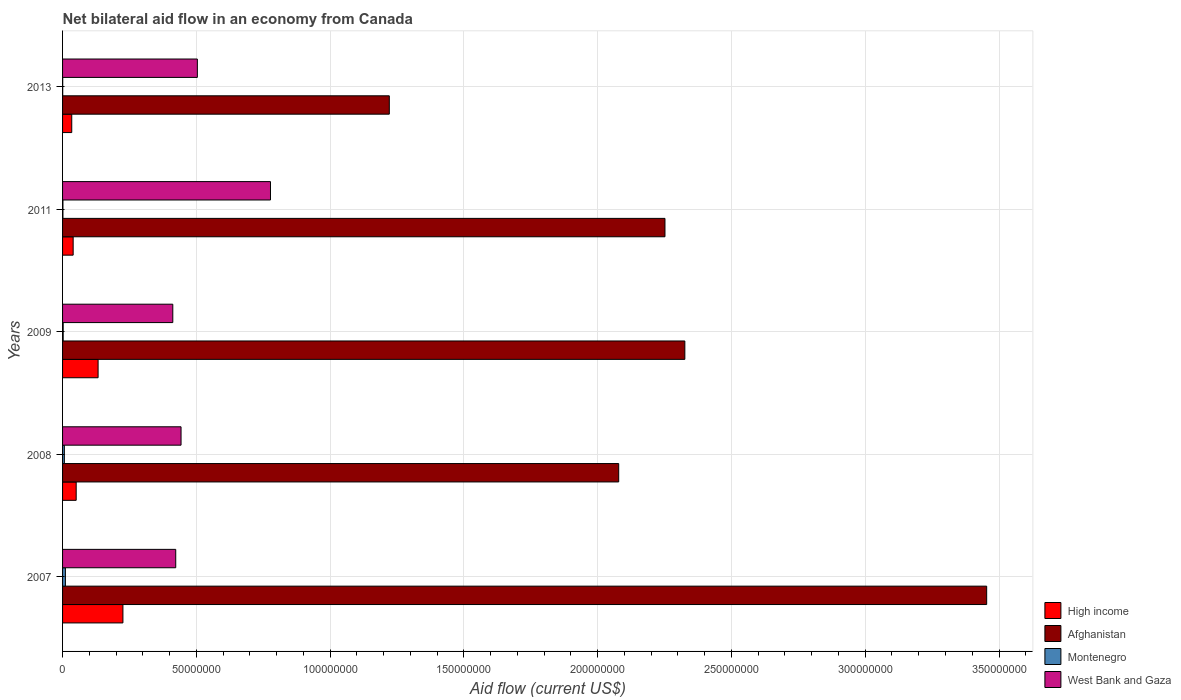How many different coloured bars are there?
Offer a very short reply. 4. How many groups of bars are there?
Offer a terse response. 5. Are the number of bars per tick equal to the number of legend labels?
Your answer should be very brief. Yes. How many bars are there on the 2nd tick from the bottom?
Your response must be concise. 4. In how many cases, is the number of bars for a given year not equal to the number of legend labels?
Ensure brevity in your answer.  0. What is the net bilateral aid flow in Afghanistan in 2011?
Keep it short and to the point. 2.25e+08. Across all years, what is the maximum net bilateral aid flow in Afghanistan?
Your answer should be very brief. 3.45e+08. What is the total net bilateral aid flow in Montenegro in the graph?
Give a very brief answer. 2.15e+06. What is the difference between the net bilateral aid flow in Montenegro in 2008 and that in 2011?
Your answer should be very brief. 5.30e+05. What is the difference between the net bilateral aid flow in Montenegro in 2009 and the net bilateral aid flow in Afghanistan in 2013?
Provide a short and direct response. -1.22e+08. In the year 2009, what is the difference between the net bilateral aid flow in Afghanistan and net bilateral aid flow in Montenegro?
Offer a very short reply. 2.32e+08. In how many years, is the net bilateral aid flow in West Bank and Gaza greater than 10000000 US$?
Offer a terse response. 5. What is the difference between the highest and the second highest net bilateral aid flow in High income?
Provide a short and direct response. 9.28e+06. What is the difference between the highest and the lowest net bilateral aid flow in Afghanistan?
Provide a succinct answer. 2.23e+08. In how many years, is the net bilateral aid flow in Montenegro greater than the average net bilateral aid flow in Montenegro taken over all years?
Give a very brief answer. 2. Is the sum of the net bilateral aid flow in Montenegro in 2007 and 2011 greater than the maximum net bilateral aid flow in West Bank and Gaza across all years?
Your answer should be compact. No. Is it the case that in every year, the sum of the net bilateral aid flow in Montenegro and net bilateral aid flow in West Bank and Gaza is greater than the sum of net bilateral aid flow in High income and net bilateral aid flow in Afghanistan?
Ensure brevity in your answer.  Yes. What does the 3rd bar from the top in 2011 represents?
Your answer should be very brief. Afghanistan. What does the 3rd bar from the bottom in 2008 represents?
Offer a terse response. Montenegro. How many bars are there?
Your answer should be compact. 20. Are all the bars in the graph horizontal?
Provide a succinct answer. Yes. How many years are there in the graph?
Your answer should be compact. 5. Are the values on the major ticks of X-axis written in scientific E-notation?
Keep it short and to the point. No. Does the graph contain grids?
Offer a very short reply. Yes. Where does the legend appear in the graph?
Your answer should be compact. Bottom right. How are the legend labels stacked?
Give a very brief answer. Vertical. What is the title of the graph?
Provide a short and direct response. Net bilateral aid flow in an economy from Canada. What is the label or title of the X-axis?
Keep it short and to the point. Aid flow (current US$). What is the label or title of the Y-axis?
Give a very brief answer. Years. What is the Aid flow (current US$) in High income in 2007?
Offer a terse response. 2.26e+07. What is the Aid flow (current US$) of Afghanistan in 2007?
Your answer should be very brief. 3.45e+08. What is the Aid flow (current US$) in Montenegro in 2007?
Offer a very short reply. 1.06e+06. What is the Aid flow (current US$) of West Bank and Gaza in 2007?
Keep it short and to the point. 4.23e+07. What is the Aid flow (current US$) of High income in 2008?
Provide a succinct answer. 5.09e+06. What is the Aid flow (current US$) in Afghanistan in 2008?
Make the answer very short. 2.08e+08. What is the Aid flow (current US$) in Montenegro in 2008?
Your answer should be compact. 6.70e+05. What is the Aid flow (current US$) in West Bank and Gaza in 2008?
Your answer should be compact. 4.43e+07. What is the Aid flow (current US$) of High income in 2009?
Provide a succinct answer. 1.33e+07. What is the Aid flow (current US$) of Afghanistan in 2009?
Ensure brevity in your answer.  2.33e+08. What is the Aid flow (current US$) in Montenegro in 2009?
Your answer should be compact. 2.30e+05. What is the Aid flow (current US$) in West Bank and Gaza in 2009?
Offer a very short reply. 4.12e+07. What is the Aid flow (current US$) in High income in 2011?
Provide a succinct answer. 3.96e+06. What is the Aid flow (current US$) of Afghanistan in 2011?
Give a very brief answer. 2.25e+08. What is the Aid flow (current US$) in Montenegro in 2011?
Make the answer very short. 1.40e+05. What is the Aid flow (current US$) in West Bank and Gaza in 2011?
Keep it short and to the point. 7.77e+07. What is the Aid flow (current US$) in High income in 2013?
Make the answer very short. 3.43e+06. What is the Aid flow (current US$) in Afghanistan in 2013?
Your answer should be compact. 1.22e+08. What is the Aid flow (current US$) in Montenegro in 2013?
Ensure brevity in your answer.  5.00e+04. What is the Aid flow (current US$) in West Bank and Gaza in 2013?
Your answer should be very brief. 5.04e+07. Across all years, what is the maximum Aid flow (current US$) in High income?
Your answer should be compact. 2.26e+07. Across all years, what is the maximum Aid flow (current US$) of Afghanistan?
Your answer should be very brief. 3.45e+08. Across all years, what is the maximum Aid flow (current US$) of Montenegro?
Your answer should be compact. 1.06e+06. Across all years, what is the maximum Aid flow (current US$) of West Bank and Gaza?
Provide a succinct answer. 7.77e+07. Across all years, what is the minimum Aid flow (current US$) in High income?
Provide a succinct answer. 3.43e+06. Across all years, what is the minimum Aid flow (current US$) in Afghanistan?
Keep it short and to the point. 1.22e+08. Across all years, what is the minimum Aid flow (current US$) of Montenegro?
Your answer should be compact. 5.00e+04. Across all years, what is the minimum Aid flow (current US$) in West Bank and Gaza?
Offer a very short reply. 4.12e+07. What is the total Aid flow (current US$) in High income in the graph?
Keep it short and to the point. 4.83e+07. What is the total Aid flow (current US$) in Afghanistan in the graph?
Keep it short and to the point. 1.13e+09. What is the total Aid flow (current US$) in Montenegro in the graph?
Your response must be concise. 2.15e+06. What is the total Aid flow (current US$) in West Bank and Gaza in the graph?
Ensure brevity in your answer.  2.56e+08. What is the difference between the Aid flow (current US$) of High income in 2007 and that in 2008?
Keep it short and to the point. 1.75e+07. What is the difference between the Aid flow (current US$) in Afghanistan in 2007 and that in 2008?
Your answer should be very brief. 1.38e+08. What is the difference between the Aid flow (current US$) of West Bank and Gaza in 2007 and that in 2008?
Offer a terse response. -1.98e+06. What is the difference between the Aid flow (current US$) in High income in 2007 and that in 2009?
Your answer should be compact. 9.28e+06. What is the difference between the Aid flow (current US$) of Afghanistan in 2007 and that in 2009?
Provide a short and direct response. 1.13e+08. What is the difference between the Aid flow (current US$) in Montenegro in 2007 and that in 2009?
Ensure brevity in your answer.  8.30e+05. What is the difference between the Aid flow (current US$) of West Bank and Gaza in 2007 and that in 2009?
Keep it short and to the point. 1.10e+06. What is the difference between the Aid flow (current US$) of High income in 2007 and that in 2011?
Offer a very short reply. 1.86e+07. What is the difference between the Aid flow (current US$) of Afghanistan in 2007 and that in 2011?
Keep it short and to the point. 1.20e+08. What is the difference between the Aid flow (current US$) of Montenegro in 2007 and that in 2011?
Provide a succinct answer. 9.20e+05. What is the difference between the Aid flow (current US$) of West Bank and Gaza in 2007 and that in 2011?
Provide a succinct answer. -3.54e+07. What is the difference between the Aid flow (current US$) of High income in 2007 and that in 2013?
Your answer should be very brief. 1.91e+07. What is the difference between the Aid flow (current US$) in Afghanistan in 2007 and that in 2013?
Provide a succinct answer. 2.23e+08. What is the difference between the Aid flow (current US$) of Montenegro in 2007 and that in 2013?
Provide a succinct answer. 1.01e+06. What is the difference between the Aid flow (current US$) in West Bank and Gaza in 2007 and that in 2013?
Your response must be concise. -8.08e+06. What is the difference between the Aid flow (current US$) in High income in 2008 and that in 2009?
Offer a terse response. -8.19e+06. What is the difference between the Aid flow (current US$) in Afghanistan in 2008 and that in 2009?
Give a very brief answer. -2.47e+07. What is the difference between the Aid flow (current US$) in Montenegro in 2008 and that in 2009?
Your answer should be compact. 4.40e+05. What is the difference between the Aid flow (current US$) of West Bank and Gaza in 2008 and that in 2009?
Your answer should be compact. 3.08e+06. What is the difference between the Aid flow (current US$) in High income in 2008 and that in 2011?
Ensure brevity in your answer.  1.13e+06. What is the difference between the Aid flow (current US$) in Afghanistan in 2008 and that in 2011?
Make the answer very short. -1.73e+07. What is the difference between the Aid flow (current US$) of Montenegro in 2008 and that in 2011?
Provide a short and direct response. 5.30e+05. What is the difference between the Aid flow (current US$) of West Bank and Gaza in 2008 and that in 2011?
Provide a short and direct response. -3.34e+07. What is the difference between the Aid flow (current US$) of High income in 2008 and that in 2013?
Your response must be concise. 1.66e+06. What is the difference between the Aid flow (current US$) in Afghanistan in 2008 and that in 2013?
Make the answer very short. 8.57e+07. What is the difference between the Aid flow (current US$) in Montenegro in 2008 and that in 2013?
Ensure brevity in your answer.  6.20e+05. What is the difference between the Aid flow (current US$) in West Bank and Gaza in 2008 and that in 2013?
Make the answer very short. -6.10e+06. What is the difference between the Aid flow (current US$) in High income in 2009 and that in 2011?
Give a very brief answer. 9.32e+06. What is the difference between the Aid flow (current US$) in Afghanistan in 2009 and that in 2011?
Keep it short and to the point. 7.43e+06. What is the difference between the Aid flow (current US$) in West Bank and Gaza in 2009 and that in 2011?
Give a very brief answer. -3.65e+07. What is the difference between the Aid flow (current US$) of High income in 2009 and that in 2013?
Offer a terse response. 9.85e+06. What is the difference between the Aid flow (current US$) of Afghanistan in 2009 and that in 2013?
Offer a terse response. 1.10e+08. What is the difference between the Aid flow (current US$) of West Bank and Gaza in 2009 and that in 2013?
Give a very brief answer. -9.18e+06. What is the difference between the Aid flow (current US$) in High income in 2011 and that in 2013?
Ensure brevity in your answer.  5.30e+05. What is the difference between the Aid flow (current US$) of Afghanistan in 2011 and that in 2013?
Keep it short and to the point. 1.03e+08. What is the difference between the Aid flow (current US$) in West Bank and Gaza in 2011 and that in 2013?
Your response must be concise. 2.73e+07. What is the difference between the Aid flow (current US$) in High income in 2007 and the Aid flow (current US$) in Afghanistan in 2008?
Your response must be concise. -1.85e+08. What is the difference between the Aid flow (current US$) of High income in 2007 and the Aid flow (current US$) of Montenegro in 2008?
Provide a short and direct response. 2.19e+07. What is the difference between the Aid flow (current US$) of High income in 2007 and the Aid flow (current US$) of West Bank and Gaza in 2008?
Provide a succinct answer. -2.17e+07. What is the difference between the Aid flow (current US$) in Afghanistan in 2007 and the Aid flow (current US$) in Montenegro in 2008?
Your answer should be compact. 3.45e+08. What is the difference between the Aid flow (current US$) of Afghanistan in 2007 and the Aid flow (current US$) of West Bank and Gaza in 2008?
Provide a succinct answer. 3.01e+08. What is the difference between the Aid flow (current US$) of Montenegro in 2007 and the Aid flow (current US$) of West Bank and Gaza in 2008?
Offer a very short reply. -4.32e+07. What is the difference between the Aid flow (current US$) in High income in 2007 and the Aid flow (current US$) in Afghanistan in 2009?
Your answer should be very brief. -2.10e+08. What is the difference between the Aid flow (current US$) in High income in 2007 and the Aid flow (current US$) in Montenegro in 2009?
Make the answer very short. 2.23e+07. What is the difference between the Aid flow (current US$) in High income in 2007 and the Aid flow (current US$) in West Bank and Gaza in 2009?
Offer a terse response. -1.86e+07. What is the difference between the Aid flow (current US$) of Afghanistan in 2007 and the Aid flow (current US$) of Montenegro in 2009?
Provide a succinct answer. 3.45e+08. What is the difference between the Aid flow (current US$) of Afghanistan in 2007 and the Aid flow (current US$) of West Bank and Gaza in 2009?
Your response must be concise. 3.04e+08. What is the difference between the Aid flow (current US$) of Montenegro in 2007 and the Aid flow (current US$) of West Bank and Gaza in 2009?
Provide a succinct answer. -4.01e+07. What is the difference between the Aid flow (current US$) in High income in 2007 and the Aid flow (current US$) in Afghanistan in 2011?
Your answer should be compact. -2.03e+08. What is the difference between the Aid flow (current US$) in High income in 2007 and the Aid flow (current US$) in Montenegro in 2011?
Your answer should be very brief. 2.24e+07. What is the difference between the Aid flow (current US$) of High income in 2007 and the Aid flow (current US$) of West Bank and Gaza in 2011?
Offer a very short reply. -5.52e+07. What is the difference between the Aid flow (current US$) of Afghanistan in 2007 and the Aid flow (current US$) of Montenegro in 2011?
Make the answer very short. 3.45e+08. What is the difference between the Aid flow (current US$) in Afghanistan in 2007 and the Aid flow (current US$) in West Bank and Gaza in 2011?
Make the answer very short. 2.68e+08. What is the difference between the Aid flow (current US$) in Montenegro in 2007 and the Aid flow (current US$) in West Bank and Gaza in 2011?
Provide a succinct answer. -7.66e+07. What is the difference between the Aid flow (current US$) in High income in 2007 and the Aid flow (current US$) in Afghanistan in 2013?
Keep it short and to the point. -9.96e+07. What is the difference between the Aid flow (current US$) in High income in 2007 and the Aid flow (current US$) in Montenegro in 2013?
Your response must be concise. 2.25e+07. What is the difference between the Aid flow (current US$) of High income in 2007 and the Aid flow (current US$) of West Bank and Gaza in 2013?
Offer a very short reply. -2.78e+07. What is the difference between the Aid flow (current US$) in Afghanistan in 2007 and the Aid flow (current US$) in Montenegro in 2013?
Offer a terse response. 3.45e+08. What is the difference between the Aid flow (current US$) of Afghanistan in 2007 and the Aid flow (current US$) of West Bank and Gaza in 2013?
Provide a short and direct response. 2.95e+08. What is the difference between the Aid flow (current US$) in Montenegro in 2007 and the Aid flow (current US$) in West Bank and Gaza in 2013?
Offer a very short reply. -4.93e+07. What is the difference between the Aid flow (current US$) of High income in 2008 and the Aid flow (current US$) of Afghanistan in 2009?
Provide a succinct answer. -2.27e+08. What is the difference between the Aid flow (current US$) of High income in 2008 and the Aid flow (current US$) of Montenegro in 2009?
Offer a very short reply. 4.86e+06. What is the difference between the Aid flow (current US$) in High income in 2008 and the Aid flow (current US$) in West Bank and Gaza in 2009?
Offer a terse response. -3.61e+07. What is the difference between the Aid flow (current US$) of Afghanistan in 2008 and the Aid flow (current US$) of Montenegro in 2009?
Make the answer very short. 2.08e+08. What is the difference between the Aid flow (current US$) in Afghanistan in 2008 and the Aid flow (current US$) in West Bank and Gaza in 2009?
Your answer should be very brief. 1.67e+08. What is the difference between the Aid flow (current US$) in Montenegro in 2008 and the Aid flow (current US$) in West Bank and Gaza in 2009?
Your response must be concise. -4.05e+07. What is the difference between the Aid flow (current US$) of High income in 2008 and the Aid flow (current US$) of Afghanistan in 2011?
Make the answer very short. -2.20e+08. What is the difference between the Aid flow (current US$) in High income in 2008 and the Aid flow (current US$) in Montenegro in 2011?
Your answer should be compact. 4.95e+06. What is the difference between the Aid flow (current US$) in High income in 2008 and the Aid flow (current US$) in West Bank and Gaza in 2011?
Offer a terse response. -7.26e+07. What is the difference between the Aid flow (current US$) of Afghanistan in 2008 and the Aid flow (current US$) of Montenegro in 2011?
Give a very brief answer. 2.08e+08. What is the difference between the Aid flow (current US$) of Afghanistan in 2008 and the Aid flow (current US$) of West Bank and Gaza in 2011?
Make the answer very short. 1.30e+08. What is the difference between the Aid flow (current US$) of Montenegro in 2008 and the Aid flow (current US$) of West Bank and Gaza in 2011?
Your answer should be very brief. -7.70e+07. What is the difference between the Aid flow (current US$) of High income in 2008 and the Aid flow (current US$) of Afghanistan in 2013?
Offer a very short reply. -1.17e+08. What is the difference between the Aid flow (current US$) of High income in 2008 and the Aid flow (current US$) of Montenegro in 2013?
Your answer should be compact. 5.04e+06. What is the difference between the Aid flow (current US$) of High income in 2008 and the Aid flow (current US$) of West Bank and Gaza in 2013?
Offer a very short reply. -4.53e+07. What is the difference between the Aid flow (current US$) of Afghanistan in 2008 and the Aid flow (current US$) of Montenegro in 2013?
Offer a very short reply. 2.08e+08. What is the difference between the Aid flow (current US$) in Afghanistan in 2008 and the Aid flow (current US$) in West Bank and Gaza in 2013?
Your answer should be very brief. 1.57e+08. What is the difference between the Aid flow (current US$) of Montenegro in 2008 and the Aid flow (current US$) of West Bank and Gaza in 2013?
Keep it short and to the point. -4.97e+07. What is the difference between the Aid flow (current US$) in High income in 2009 and the Aid flow (current US$) in Afghanistan in 2011?
Make the answer very short. -2.12e+08. What is the difference between the Aid flow (current US$) of High income in 2009 and the Aid flow (current US$) of Montenegro in 2011?
Offer a terse response. 1.31e+07. What is the difference between the Aid flow (current US$) in High income in 2009 and the Aid flow (current US$) in West Bank and Gaza in 2011?
Keep it short and to the point. -6.44e+07. What is the difference between the Aid flow (current US$) of Afghanistan in 2009 and the Aid flow (current US$) of Montenegro in 2011?
Your answer should be very brief. 2.32e+08. What is the difference between the Aid flow (current US$) of Afghanistan in 2009 and the Aid flow (current US$) of West Bank and Gaza in 2011?
Offer a very short reply. 1.55e+08. What is the difference between the Aid flow (current US$) of Montenegro in 2009 and the Aid flow (current US$) of West Bank and Gaza in 2011?
Provide a short and direct response. -7.75e+07. What is the difference between the Aid flow (current US$) in High income in 2009 and the Aid flow (current US$) in Afghanistan in 2013?
Your response must be concise. -1.09e+08. What is the difference between the Aid flow (current US$) of High income in 2009 and the Aid flow (current US$) of Montenegro in 2013?
Your answer should be compact. 1.32e+07. What is the difference between the Aid flow (current US$) of High income in 2009 and the Aid flow (current US$) of West Bank and Gaza in 2013?
Provide a succinct answer. -3.71e+07. What is the difference between the Aid flow (current US$) of Afghanistan in 2009 and the Aid flow (current US$) of Montenegro in 2013?
Make the answer very short. 2.33e+08. What is the difference between the Aid flow (current US$) in Afghanistan in 2009 and the Aid flow (current US$) in West Bank and Gaza in 2013?
Provide a succinct answer. 1.82e+08. What is the difference between the Aid flow (current US$) in Montenegro in 2009 and the Aid flow (current US$) in West Bank and Gaza in 2013?
Keep it short and to the point. -5.02e+07. What is the difference between the Aid flow (current US$) in High income in 2011 and the Aid flow (current US$) in Afghanistan in 2013?
Provide a short and direct response. -1.18e+08. What is the difference between the Aid flow (current US$) in High income in 2011 and the Aid flow (current US$) in Montenegro in 2013?
Make the answer very short. 3.91e+06. What is the difference between the Aid flow (current US$) of High income in 2011 and the Aid flow (current US$) of West Bank and Gaza in 2013?
Offer a very short reply. -4.64e+07. What is the difference between the Aid flow (current US$) in Afghanistan in 2011 and the Aid flow (current US$) in Montenegro in 2013?
Offer a very short reply. 2.25e+08. What is the difference between the Aid flow (current US$) in Afghanistan in 2011 and the Aid flow (current US$) in West Bank and Gaza in 2013?
Provide a succinct answer. 1.75e+08. What is the difference between the Aid flow (current US$) of Montenegro in 2011 and the Aid flow (current US$) of West Bank and Gaza in 2013?
Provide a succinct answer. -5.02e+07. What is the average Aid flow (current US$) in High income per year?
Provide a short and direct response. 9.66e+06. What is the average Aid flow (current US$) of Afghanistan per year?
Provide a succinct answer. 2.27e+08. What is the average Aid flow (current US$) of West Bank and Gaza per year?
Give a very brief answer. 5.12e+07. In the year 2007, what is the difference between the Aid flow (current US$) in High income and Aid flow (current US$) in Afghanistan?
Offer a terse response. -3.23e+08. In the year 2007, what is the difference between the Aid flow (current US$) of High income and Aid flow (current US$) of Montenegro?
Offer a terse response. 2.15e+07. In the year 2007, what is the difference between the Aid flow (current US$) of High income and Aid flow (current US$) of West Bank and Gaza?
Keep it short and to the point. -1.97e+07. In the year 2007, what is the difference between the Aid flow (current US$) of Afghanistan and Aid flow (current US$) of Montenegro?
Give a very brief answer. 3.44e+08. In the year 2007, what is the difference between the Aid flow (current US$) in Afghanistan and Aid flow (current US$) in West Bank and Gaza?
Your answer should be very brief. 3.03e+08. In the year 2007, what is the difference between the Aid flow (current US$) in Montenegro and Aid flow (current US$) in West Bank and Gaza?
Keep it short and to the point. -4.12e+07. In the year 2008, what is the difference between the Aid flow (current US$) in High income and Aid flow (current US$) in Afghanistan?
Offer a very short reply. -2.03e+08. In the year 2008, what is the difference between the Aid flow (current US$) of High income and Aid flow (current US$) of Montenegro?
Ensure brevity in your answer.  4.42e+06. In the year 2008, what is the difference between the Aid flow (current US$) of High income and Aid flow (current US$) of West Bank and Gaza?
Make the answer very short. -3.92e+07. In the year 2008, what is the difference between the Aid flow (current US$) of Afghanistan and Aid flow (current US$) of Montenegro?
Offer a very short reply. 2.07e+08. In the year 2008, what is the difference between the Aid flow (current US$) of Afghanistan and Aid flow (current US$) of West Bank and Gaza?
Offer a terse response. 1.64e+08. In the year 2008, what is the difference between the Aid flow (current US$) of Montenegro and Aid flow (current US$) of West Bank and Gaza?
Your answer should be very brief. -4.36e+07. In the year 2009, what is the difference between the Aid flow (current US$) in High income and Aid flow (current US$) in Afghanistan?
Ensure brevity in your answer.  -2.19e+08. In the year 2009, what is the difference between the Aid flow (current US$) of High income and Aid flow (current US$) of Montenegro?
Give a very brief answer. 1.30e+07. In the year 2009, what is the difference between the Aid flow (current US$) in High income and Aid flow (current US$) in West Bank and Gaza?
Offer a terse response. -2.79e+07. In the year 2009, what is the difference between the Aid flow (current US$) of Afghanistan and Aid flow (current US$) of Montenegro?
Keep it short and to the point. 2.32e+08. In the year 2009, what is the difference between the Aid flow (current US$) of Afghanistan and Aid flow (current US$) of West Bank and Gaza?
Offer a terse response. 1.91e+08. In the year 2009, what is the difference between the Aid flow (current US$) in Montenegro and Aid flow (current US$) in West Bank and Gaza?
Offer a very short reply. -4.10e+07. In the year 2011, what is the difference between the Aid flow (current US$) of High income and Aid flow (current US$) of Afghanistan?
Your answer should be very brief. -2.21e+08. In the year 2011, what is the difference between the Aid flow (current US$) of High income and Aid flow (current US$) of Montenegro?
Your response must be concise. 3.82e+06. In the year 2011, what is the difference between the Aid flow (current US$) of High income and Aid flow (current US$) of West Bank and Gaza?
Ensure brevity in your answer.  -7.38e+07. In the year 2011, what is the difference between the Aid flow (current US$) of Afghanistan and Aid flow (current US$) of Montenegro?
Your response must be concise. 2.25e+08. In the year 2011, what is the difference between the Aid flow (current US$) in Afghanistan and Aid flow (current US$) in West Bank and Gaza?
Your response must be concise. 1.47e+08. In the year 2011, what is the difference between the Aid flow (current US$) in Montenegro and Aid flow (current US$) in West Bank and Gaza?
Your answer should be compact. -7.76e+07. In the year 2013, what is the difference between the Aid flow (current US$) in High income and Aid flow (current US$) in Afghanistan?
Make the answer very short. -1.19e+08. In the year 2013, what is the difference between the Aid flow (current US$) of High income and Aid flow (current US$) of Montenegro?
Offer a very short reply. 3.38e+06. In the year 2013, what is the difference between the Aid flow (current US$) of High income and Aid flow (current US$) of West Bank and Gaza?
Provide a succinct answer. -4.70e+07. In the year 2013, what is the difference between the Aid flow (current US$) in Afghanistan and Aid flow (current US$) in Montenegro?
Make the answer very short. 1.22e+08. In the year 2013, what is the difference between the Aid flow (current US$) in Afghanistan and Aid flow (current US$) in West Bank and Gaza?
Offer a terse response. 7.17e+07. In the year 2013, what is the difference between the Aid flow (current US$) in Montenegro and Aid flow (current US$) in West Bank and Gaza?
Keep it short and to the point. -5.03e+07. What is the ratio of the Aid flow (current US$) in High income in 2007 to that in 2008?
Your answer should be compact. 4.43. What is the ratio of the Aid flow (current US$) of Afghanistan in 2007 to that in 2008?
Ensure brevity in your answer.  1.66. What is the ratio of the Aid flow (current US$) in Montenegro in 2007 to that in 2008?
Give a very brief answer. 1.58. What is the ratio of the Aid flow (current US$) in West Bank and Gaza in 2007 to that in 2008?
Your response must be concise. 0.96. What is the ratio of the Aid flow (current US$) in High income in 2007 to that in 2009?
Your answer should be very brief. 1.7. What is the ratio of the Aid flow (current US$) of Afghanistan in 2007 to that in 2009?
Offer a very short reply. 1.49. What is the ratio of the Aid flow (current US$) of Montenegro in 2007 to that in 2009?
Your answer should be compact. 4.61. What is the ratio of the Aid flow (current US$) of West Bank and Gaza in 2007 to that in 2009?
Provide a short and direct response. 1.03. What is the ratio of the Aid flow (current US$) of High income in 2007 to that in 2011?
Give a very brief answer. 5.7. What is the ratio of the Aid flow (current US$) in Afghanistan in 2007 to that in 2011?
Ensure brevity in your answer.  1.53. What is the ratio of the Aid flow (current US$) of Montenegro in 2007 to that in 2011?
Your answer should be very brief. 7.57. What is the ratio of the Aid flow (current US$) in West Bank and Gaza in 2007 to that in 2011?
Give a very brief answer. 0.54. What is the ratio of the Aid flow (current US$) of High income in 2007 to that in 2013?
Give a very brief answer. 6.58. What is the ratio of the Aid flow (current US$) in Afghanistan in 2007 to that in 2013?
Your answer should be compact. 2.83. What is the ratio of the Aid flow (current US$) in Montenegro in 2007 to that in 2013?
Make the answer very short. 21.2. What is the ratio of the Aid flow (current US$) of West Bank and Gaza in 2007 to that in 2013?
Ensure brevity in your answer.  0.84. What is the ratio of the Aid flow (current US$) in High income in 2008 to that in 2009?
Give a very brief answer. 0.38. What is the ratio of the Aid flow (current US$) of Afghanistan in 2008 to that in 2009?
Provide a succinct answer. 0.89. What is the ratio of the Aid flow (current US$) in Montenegro in 2008 to that in 2009?
Give a very brief answer. 2.91. What is the ratio of the Aid flow (current US$) in West Bank and Gaza in 2008 to that in 2009?
Keep it short and to the point. 1.07. What is the ratio of the Aid flow (current US$) in High income in 2008 to that in 2011?
Your answer should be compact. 1.29. What is the ratio of the Aid flow (current US$) in Afghanistan in 2008 to that in 2011?
Provide a short and direct response. 0.92. What is the ratio of the Aid flow (current US$) in Montenegro in 2008 to that in 2011?
Offer a very short reply. 4.79. What is the ratio of the Aid flow (current US$) in West Bank and Gaza in 2008 to that in 2011?
Your answer should be very brief. 0.57. What is the ratio of the Aid flow (current US$) in High income in 2008 to that in 2013?
Give a very brief answer. 1.48. What is the ratio of the Aid flow (current US$) of Afghanistan in 2008 to that in 2013?
Your response must be concise. 1.7. What is the ratio of the Aid flow (current US$) of Montenegro in 2008 to that in 2013?
Provide a short and direct response. 13.4. What is the ratio of the Aid flow (current US$) in West Bank and Gaza in 2008 to that in 2013?
Your answer should be very brief. 0.88. What is the ratio of the Aid flow (current US$) in High income in 2009 to that in 2011?
Ensure brevity in your answer.  3.35. What is the ratio of the Aid flow (current US$) of Afghanistan in 2009 to that in 2011?
Offer a very short reply. 1.03. What is the ratio of the Aid flow (current US$) in Montenegro in 2009 to that in 2011?
Give a very brief answer. 1.64. What is the ratio of the Aid flow (current US$) in West Bank and Gaza in 2009 to that in 2011?
Your answer should be very brief. 0.53. What is the ratio of the Aid flow (current US$) in High income in 2009 to that in 2013?
Your answer should be compact. 3.87. What is the ratio of the Aid flow (current US$) in Afghanistan in 2009 to that in 2013?
Your answer should be very brief. 1.9. What is the ratio of the Aid flow (current US$) in West Bank and Gaza in 2009 to that in 2013?
Your answer should be very brief. 0.82. What is the ratio of the Aid flow (current US$) of High income in 2011 to that in 2013?
Make the answer very short. 1.15. What is the ratio of the Aid flow (current US$) of Afghanistan in 2011 to that in 2013?
Provide a short and direct response. 1.84. What is the ratio of the Aid flow (current US$) of Montenegro in 2011 to that in 2013?
Ensure brevity in your answer.  2.8. What is the ratio of the Aid flow (current US$) of West Bank and Gaza in 2011 to that in 2013?
Offer a terse response. 1.54. What is the difference between the highest and the second highest Aid flow (current US$) of High income?
Your answer should be very brief. 9.28e+06. What is the difference between the highest and the second highest Aid flow (current US$) of Afghanistan?
Provide a short and direct response. 1.13e+08. What is the difference between the highest and the second highest Aid flow (current US$) of Montenegro?
Provide a short and direct response. 3.90e+05. What is the difference between the highest and the second highest Aid flow (current US$) of West Bank and Gaza?
Your answer should be very brief. 2.73e+07. What is the difference between the highest and the lowest Aid flow (current US$) in High income?
Provide a short and direct response. 1.91e+07. What is the difference between the highest and the lowest Aid flow (current US$) of Afghanistan?
Ensure brevity in your answer.  2.23e+08. What is the difference between the highest and the lowest Aid flow (current US$) of Montenegro?
Provide a succinct answer. 1.01e+06. What is the difference between the highest and the lowest Aid flow (current US$) in West Bank and Gaza?
Ensure brevity in your answer.  3.65e+07. 